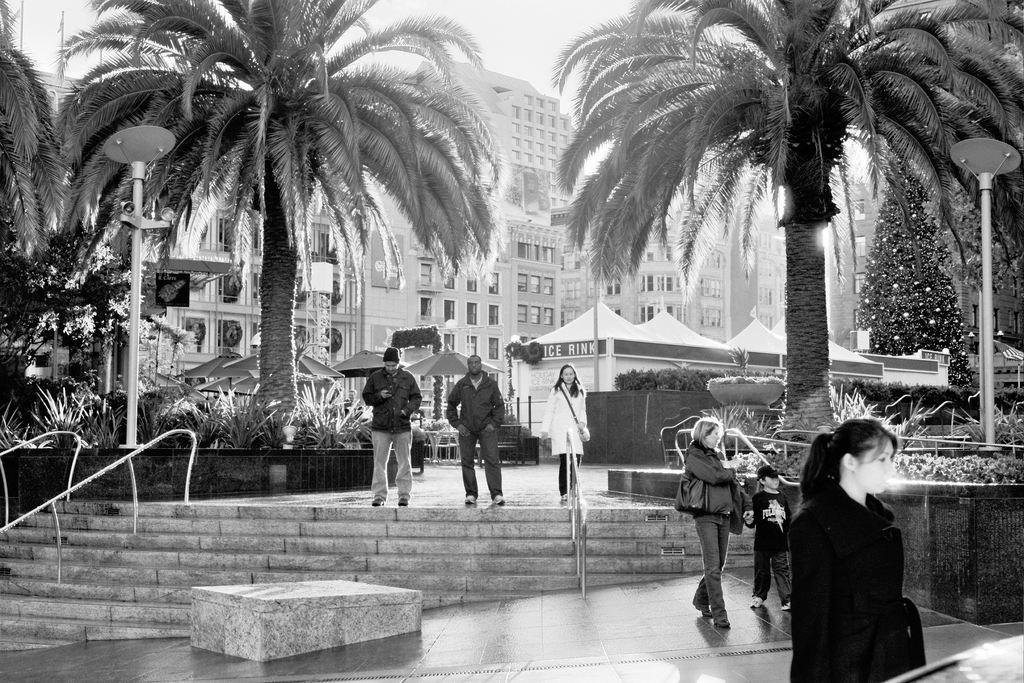Who or what can be seen in the image? There are people in the image. What type of surface is visible at the bottom of the image? There is stone visible at the bottom of the image. What type of vegetation is in the middle of the image? There are trees in the middle of the image. What type of structures are present in the image? There are buildings in the image. What type of drink is being served in the image? There is no drink visible in the image. Can you describe the detail of the eggnog in the image? There is no eggnog present in the image. 